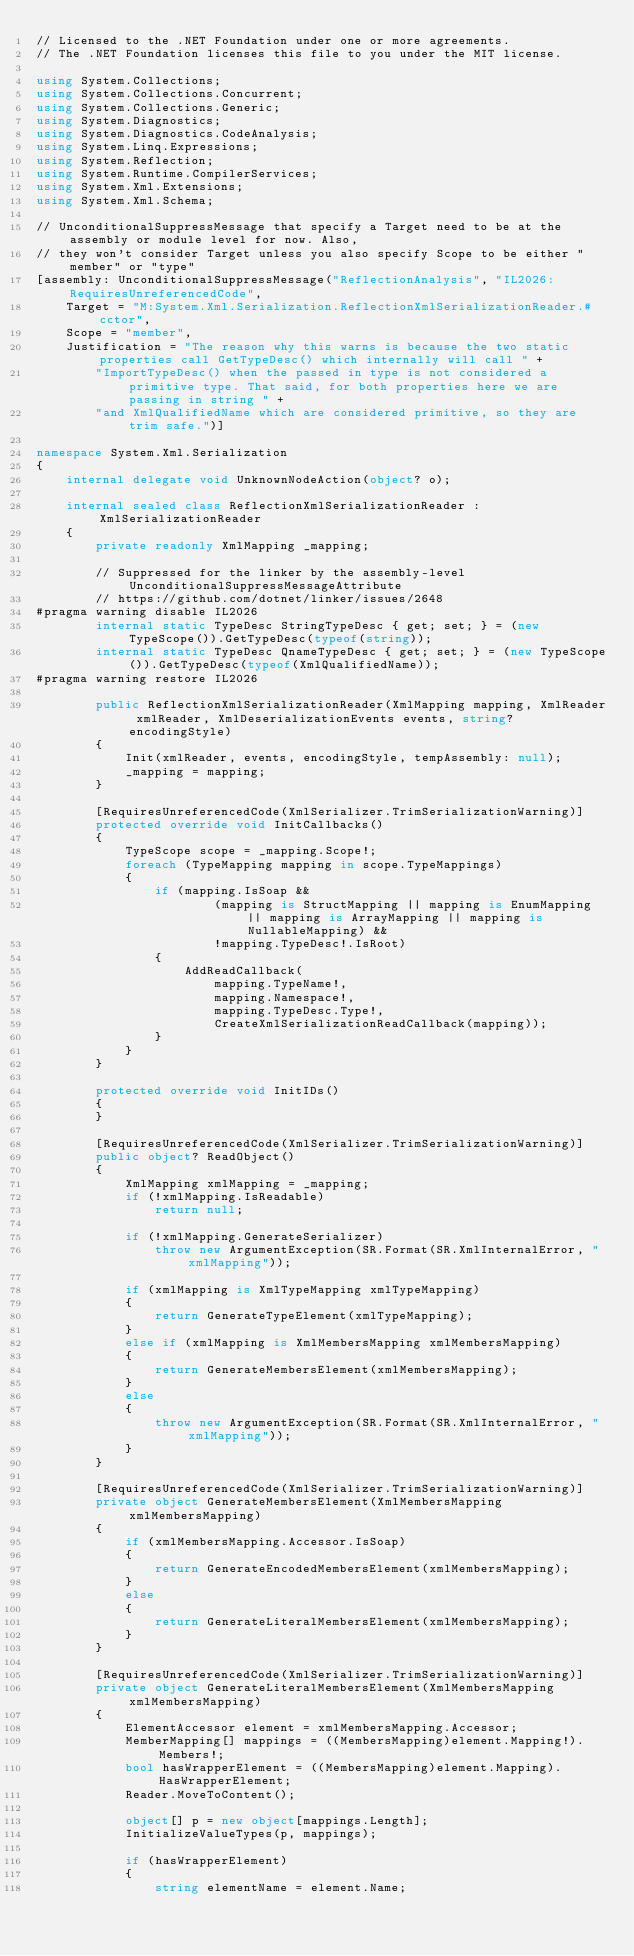Convert code to text. <code><loc_0><loc_0><loc_500><loc_500><_C#_>// Licensed to the .NET Foundation under one or more agreements.
// The .NET Foundation licenses this file to you under the MIT license.

using System.Collections;
using System.Collections.Concurrent;
using System.Collections.Generic;
using System.Diagnostics;
using System.Diagnostics.CodeAnalysis;
using System.Linq.Expressions;
using System.Reflection;
using System.Runtime.CompilerServices;
using System.Xml.Extensions;
using System.Xml.Schema;

// UnconditionalSuppressMessage that specify a Target need to be at the assembly or module level for now. Also,
// they won't consider Target unless you also specify Scope to be either "member" or "type"
[assembly: UnconditionalSuppressMessage("ReflectionAnalysis", "IL2026:RequiresUnreferencedCode",
    Target = "M:System.Xml.Serialization.ReflectionXmlSerializationReader.#cctor",
    Scope = "member",
    Justification = "The reason why this warns is because the two static properties call GetTypeDesc() which internally will call " +
        "ImportTypeDesc() when the passed in type is not considered a primitive type. That said, for both properties here we are passing in string " +
        "and XmlQualifiedName which are considered primitive, so they are trim safe.")]

namespace System.Xml.Serialization
{
    internal delegate void UnknownNodeAction(object? o);

    internal sealed class ReflectionXmlSerializationReader : XmlSerializationReader
    {
        private readonly XmlMapping _mapping;

        // Suppressed for the linker by the assembly-level UnconditionalSuppressMessageAttribute
        // https://github.com/dotnet/linker/issues/2648
#pragma warning disable IL2026
        internal static TypeDesc StringTypeDesc { get; set; } = (new TypeScope()).GetTypeDesc(typeof(string));
        internal static TypeDesc QnameTypeDesc { get; set; } = (new TypeScope()).GetTypeDesc(typeof(XmlQualifiedName));
#pragma warning restore IL2026

        public ReflectionXmlSerializationReader(XmlMapping mapping, XmlReader xmlReader, XmlDeserializationEvents events, string? encodingStyle)
        {
            Init(xmlReader, events, encodingStyle, tempAssembly: null);
            _mapping = mapping;
        }

        [RequiresUnreferencedCode(XmlSerializer.TrimSerializationWarning)]
        protected override void InitCallbacks()
        {
            TypeScope scope = _mapping.Scope!;
            foreach (TypeMapping mapping in scope.TypeMappings)
            {
                if (mapping.IsSoap &&
                        (mapping is StructMapping || mapping is EnumMapping || mapping is ArrayMapping || mapping is NullableMapping) &&
                        !mapping.TypeDesc!.IsRoot)
                {
                    AddReadCallback(
                        mapping.TypeName!,
                        mapping.Namespace!,
                        mapping.TypeDesc.Type!,
                        CreateXmlSerializationReadCallback(mapping));
                }
            }
        }

        protected override void InitIDs()
        {
        }

        [RequiresUnreferencedCode(XmlSerializer.TrimSerializationWarning)]
        public object? ReadObject()
        {
            XmlMapping xmlMapping = _mapping;
            if (!xmlMapping.IsReadable)
                return null;

            if (!xmlMapping.GenerateSerializer)
                throw new ArgumentException(SR.Format(SR.XmlInternalError, "xmlMapping"));

            if (xmlMapping is XmlTypeMapping xmlTypeMapping)
            {
                return GenerateTypeElement(xmlTypeMapping);
            }
            else if (xmlMapping is XmlMembersMapping xmlMembersMapping)
            {
                return GenerateMembersElement(xmlMembersMapping);
            }
            else
            {
                throw new ArgumentException(SR.Format(SR.XmlInternalError, "xmlMapping"));
            }
        }

        [RequiresUnreferencedCode(XmlSerializer.TrimSerializationWarning)]
        private object GenerateMembersElement(XmlMembersMapping xmlMembersMapping)
        {
            if (xmlMembersMapping.Accessor.IsSoap)
            {
                return GenerateEncodedMembersElement(xmlMembersMapping);
            }
            else
            {
                return GenerateLiteralMembersElement(xmlMembersMapping);
            }
        }

        [RequiresUnreferencedCode(XmlSerializer.TrimSerializationWarning)]
        private object GenerateLiteralMembersElement(XmlMembersMapping xmlMembersMapping)
        {
            ElementAccessor element = xmlMembersMapping.Accessor;
            MemberMapping[] mappings = ((MembersMapping)element.Mapping!).Members!;
            bool hasWrapperElement = ((MembersMapping)element.Mapping).HasWrapperElement;
            Reader.MoveToContent();

            object[] p = new object[mappings.Length];
            InitializeValueTypes(p, mappings);

            if (hasWrapperElement)
            {
                string elementName = element.Name;</code> 